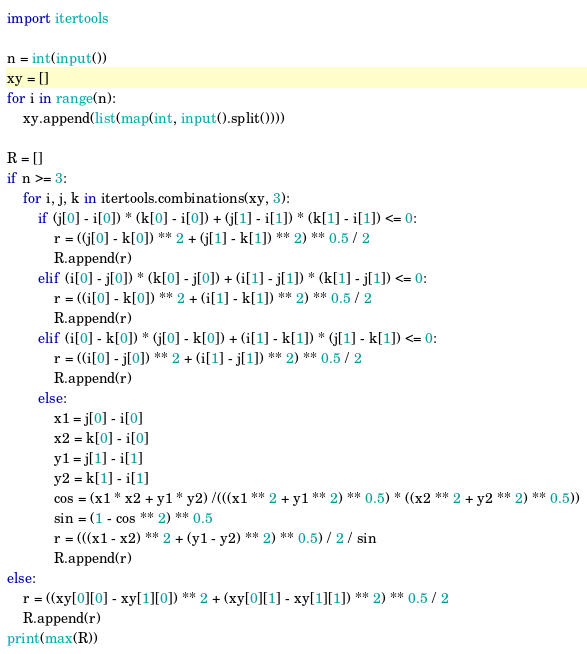Convert code to text. <code><loc_0><loc_0><loc_500><loc_500><_Python_>import itertools

n = int(input())
xy = []
for i in range(n):
    xy.append(list(map(int, input().split())))

R = []
if n >= 3:
    for i, j, k in itertools.combinations(xy, 3):
        if (j[0] - i[0]) * (k[0] - i[0]) + (j[1] - i[1]) * (k[1] - i[1]) <= 0:
            r = ((j[0] - k[0]) ** 2 + (j[1] - k[1]) ** 2) ** 0.5 / 2
            R.append(r)
        elif (i[0] - j[0]) * (k[0] - j[0]) + (i[1] - j[1]) * (k[1] - j[1]) <= 0:
            r = ((i[0] - k[0]) ** 2 + (i[1] - k[1]) ** 2) ** 0.5 / 2
            R.append(r)
        elif (i[0] - k[0]) * (j[0] - k[0]) + (i[1] - k[1]) * (j[1] - k[1]) <= 0:
            r = ((i[0] - j[0]) ** 2 + (i[1] - j[1]) ** 2) ** 0.5 / 2
            R.append(r)
        else:
            x1 = j[0] - i[0]
            x2 = k[0] - i[0]
            y1 = j[1] - i[1]
            y2 = k[1] - i[1]
            cos = (x1 * x2 + y1 * y2) /(((x1 ** 2 + y1 ** 2) ** 0.5) * ((x2 ** 2 + y2 ** 2) ** 0.5))
            sin = (1 - cos ** 2) ** 0.5
            r = (((x1 - x2) ** 2 + (y1 - y2) ** 2) ** 0.5) / 2 / sin
            R.append(r)
else:
    r = ((xy[0][0] - xy[1][0]) ** 2 + (xy[0][1] - xy[1][1]) ** 2) ** 0.5 / 2
    R.append(r)
print(max(R))</code> 